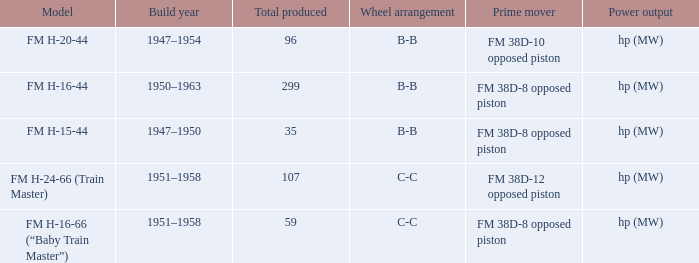Which is the smallest Total produced with a model of FM H-15-44? 35.0. 